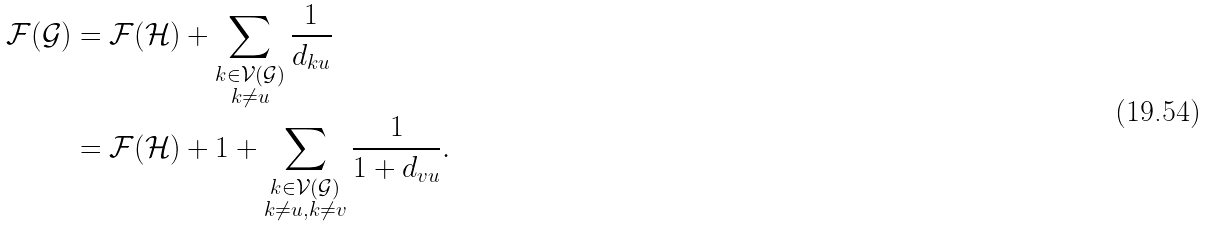<formula> <loc_0><loc_0><loc_500><loc_500>\mathcal { F } ( \mathcal { G } ) & = \mathcal { F } ( \mathcal { H } ) + \sum _ { \substack { k \in \mathcal { V } ( \mathcal { G } ) \\ k \neq u } } \frac { 1 } { d _ { k u } } \\ & = \mathcal { F } ( \mathcal { H } ) + 1 + \sum _ { \substack { k \in \mathcal { V } ( \mathcal { G } ) \\ k \neq u , k \neq v } } \frac { 1 } { 1 + d _ { v u } } . \\</formula> 